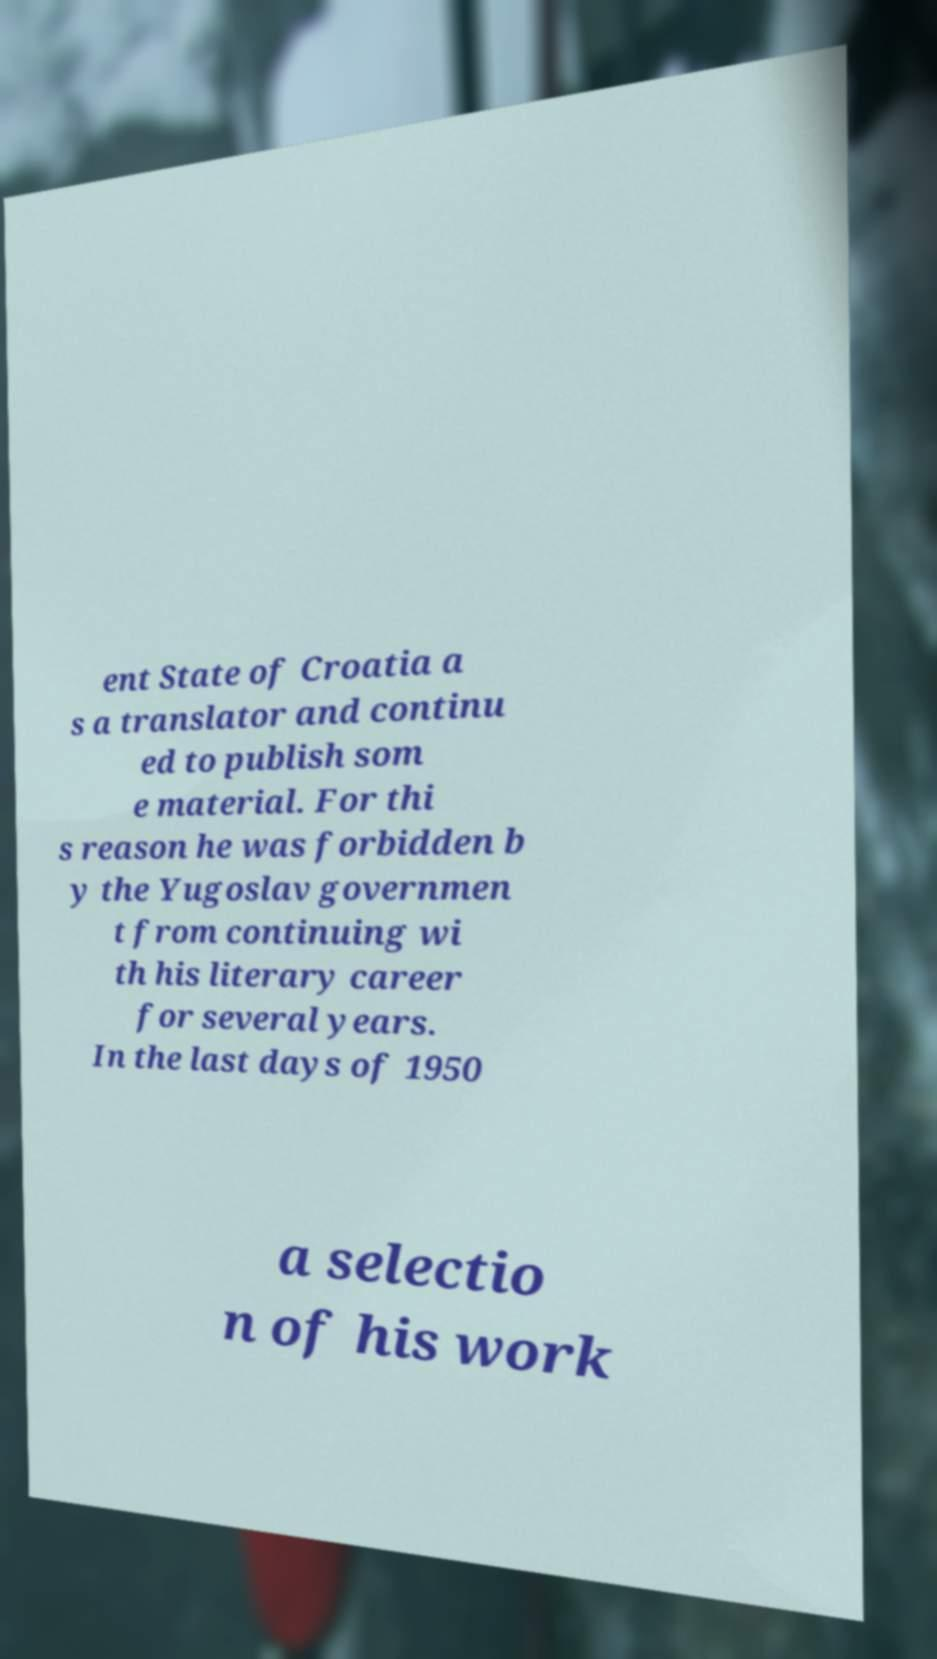Please read and relay the text visible in this image. What does it say? ent State of Croatia a s a translator and continu ed to publish som e material. For thi s reason he was forbidden b y the Yugoslav governmen t from continuing wi th his literary career for several years. In the last days of 1950 a selectio n of his work 